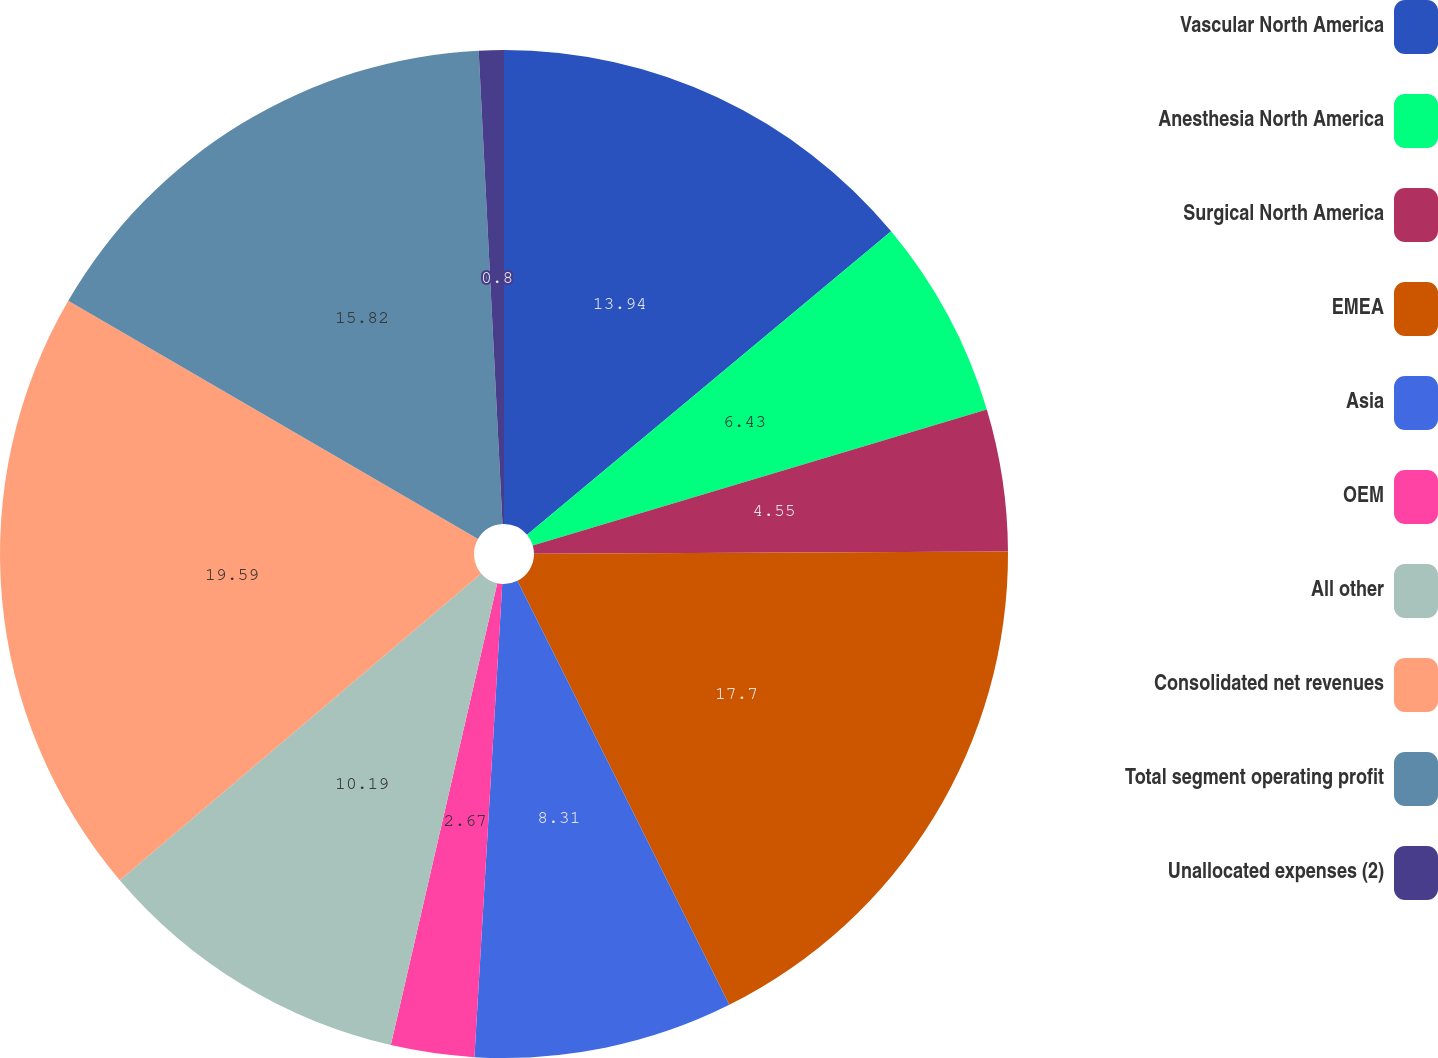Convert chart. <chart><loc_0><loc_0><loc_500><loc_500><pie_chart><fcel>Vascular North America<fcel>Anesthesia North America<fcel>Surgical North America<fcel>EMEA<fcel>Asia<fcel>OEM<fcel>All other<fcel>Consolidated net revenues<fcel>Total segment operating profit<fcel>Unallocated expenses (2)<nl><fcel>13.94%<fcel>6.43%<fcel>4.55%<fcel>17.7%<fcel>8.31%<fcel>2.67%<fcel>10.19%<fcel>19.58%<fcel>15.82%<fcel>0.8%<nl></chart> 